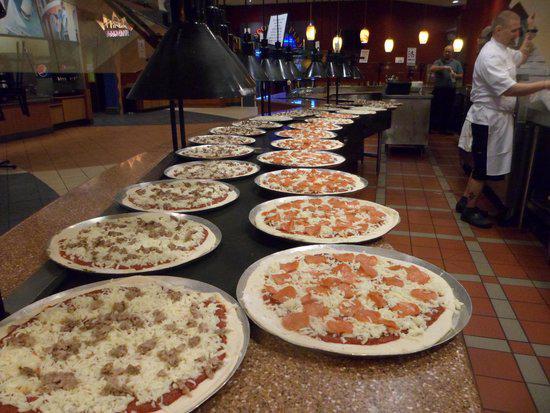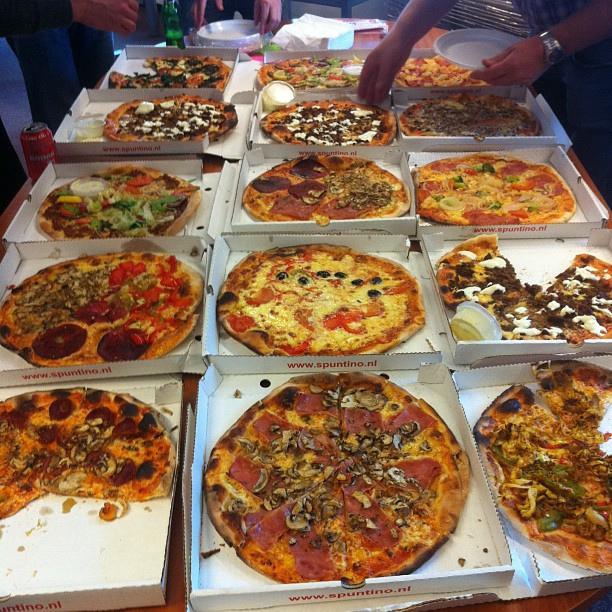The first image is the image on the left, the second image is the image on the right. Analyze the images presented: Is the assertion "The pizzas in the image on the right are still in their boxes." valid? Answer yes or no. Yes. The first image is the image on the left, the second image is the image on the right. Considering the images on both sides, is "All pizzas in the right image are in boxes." valid? Answer yes or no. Yes. 